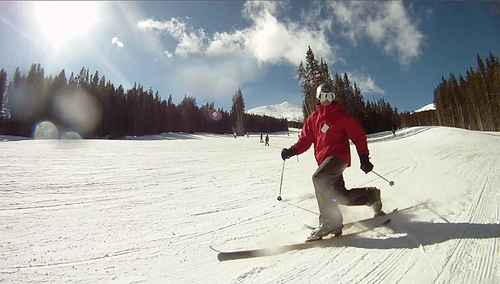What is causing the glare in the image? The glare in the image appears to be caused by the sun. You can tell because the light source is large and diffuse, characteristic of sunlight, and the sky is clear which often accompanies a sun-induced glare. Additionally, the way the light is scattered in the sky and the presence of long shadows on the snow further suggests that the sun is the source of the glare. 